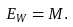Convert formula to latex. <formula><loc_0><loc_0><loc_500><loc_500>E _ { W } = M .</formula> 